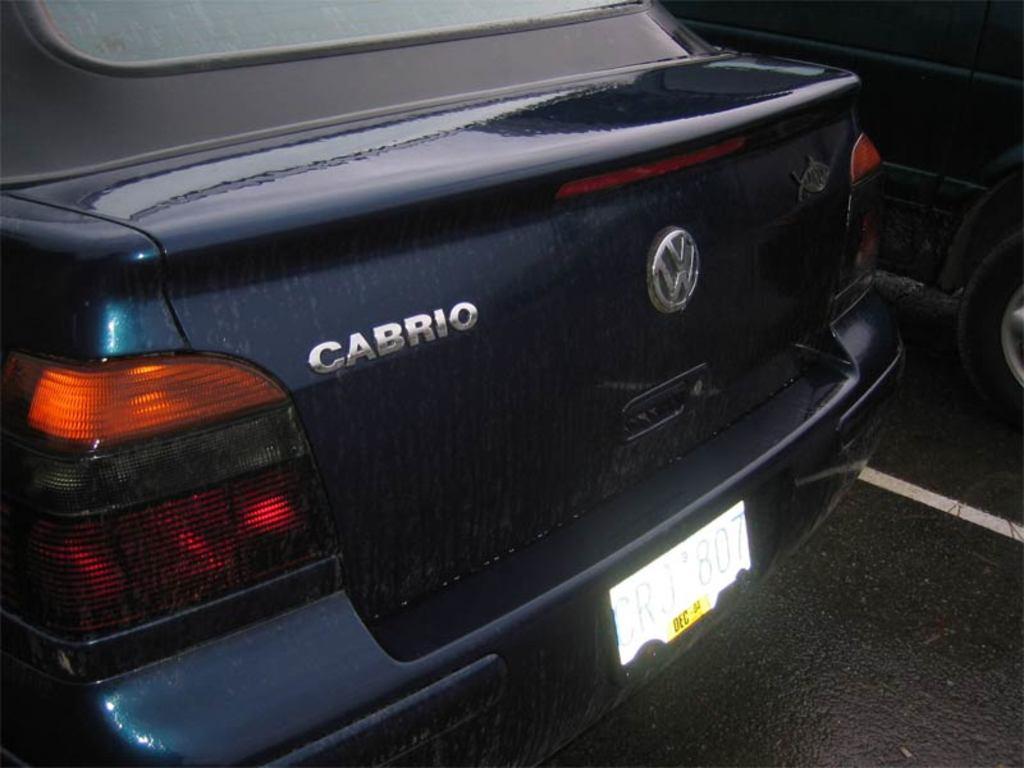How would you summarize this image in a sentence or two? We can see cars on the road. 